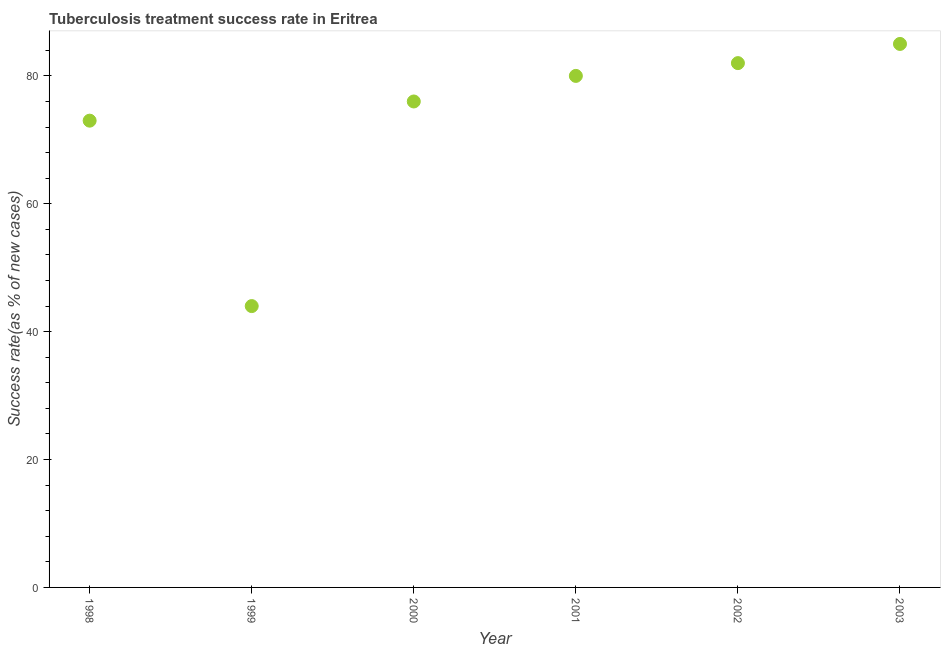What is the tuberculosis treatment success rate in 1998?
Offer a very short reply. 73. Across all years, what is the maximum tuberculosis treatment success rate?
Your answer should be compact. 85. Across all years, what is the minimum tuberculosis treatment success rate?
Your answer should be very brief. 44. In which year was the tuberculosis treatment success rate minimum?
Provide a succinct answer. 1999. What is the sum of the tuberculosis treatment success rate?
Make the answer very short. 440. What is the difference between the tuberculosis treatment success rate in 2000 and 2003?
Make the answer very short. -9. What is the average tuberculosis treatment success rate per year?
Your response must be concise. 73.33. In how many years, is the tuberculosis treatment success rate greater than 44 %?
Provide a succinct answer. 5. Do a majority of the years between 1999 and 2003 (inclusive) have tuberculosis treatment success rate greater than 36 %?
Make the answer very short. Yes. What is the ratio of the tuberculosis treatment success rate in 2000 to that in 2003?
Provide a succinct answer. 0.89. Is the tuberculosis treatment success rate in 2000 less than that in 2001?
Your answer should be compact. Yes. Is the difference between the tuberculosis treatment success rate in 1999 and 2003 greater than the difference between any two years?
Keep it short and to the point. Yes. What is the difference between the highest and the second highest tuberculosis treatment success rate?
Give a very brief answer. 3. Is the sum of the tuberculosis treatment success rate in 2002 and 2003 greater than the maximum tuberculosis treatment success rate across all years?
Your answer should be very brief. Yes. What is the difference between the highest and the lowest tuberculosis treatment success rate?
Keep it short and to the point. 41. Does the tuberculosis treatment success rate monotonically increase over the years?
Ensure brevity in your answer.  No. How many dotlines are there?
Give a very brief answer. 1. Are the values on the major ticks of Y-axis written in scientific E-notation?
Your answer should be compact. No. Does the graph contain any zero values?
Provide a short and direct response. No. What is the title of the graph?
Offer a terse response. Tuberculosis treatment success rate in Eritrea. What is the label or title of the Y-axis?
Keep it short and to the point. Success rate(as % of new cases). What is the Success rate(as % of new cases) in 1999?
Offer a very short reply. 44. What is the Success rate(as % of new cases) in 2000?
Make the answer very short. 76. What is the Success rate(as % of new cases) in 2001?
Offer a very short reply. 80. What is the difference between the Success rate(as % of new cases) in 1998 and 2000?
Your answer should be compact. -3. What is the difference between the Success rate(as % of new cases) in 1998 and 2001?
Offer a very short reply. -7. What is the difference between the Success rate(as % of new cases) in 1999 and 2000?
Give a very brief answer. -32. What is the difference between the Success rate(as % of new cases) in 1999 and 2001?
Your answer should be compact. -36. What is the difference between the Success rate(as % of new cases) in 1999 and 2002?
Offer a terse response. -38. What is the difference between the Success rate(as % of new cases) in 1999 and 2003?
Your answer should be very brief. -41. What is the difference between the Success rate(as % of new cases) in 2000 and 2002?
Provide a succinct answer. -6. What is the difference between the Success rate(as % of new cases) in 2001 and 2002?
Ensure brevity in your answer.  -2. What is the difference between the Success rate(as % of new cases) in 2001 and 2003?
Your response must be concise. -5. What is the difference between the Success rate(as % of new cases) in 2002 and 2003?
Make the answer very short. -3. What is the ratio of the Success rate(as % of new cases) in 1998 to that in 1999?
Provide a succinct answer. 1.66. What is the ratio of the Success rate(as % of new cases) in 1998 to that in 2000?
Your answer should be very brief. 0.96. What is the ratio of the Success rate(as % of new cases) in 1998 to that in 2001?
Ensure brevity in your answer.  0.91. What is the ratio of the Success rate(as % of new cases) in 1998 to that in 2002?
Provide a succinct answer. 0.89. What is the ratio of the Success rate(as % of new cases) in 1998 to that in 2003?
Your answer should be compact. 0.86. What is the ratio of the Success rate(as % of new cases) in 1999 to that in 2000?
Your answer should be very brief. 0.58. What is the ratio of the Success rate(as % of new cases) in 1999 to that in 2001?
Ensure brevity in your answer.  0.55. What is the ratio of the Success rate(as % of new cases) in 1999 to that in 2002?
Give a very brief answer. 0.54. What is the ratio of the Success rate(as % of new cases) in 1999 to that in 2003?
Offer a terse response. 0.52. What is the ratio of the Success rate(as % of new cases) in 2000 to that in 2002?
Offer a terse response. 0.93. What is the ratio of the Success rate(as % of new cases) in 2000 to that in 2003?
Offer a terse response. 0.89. What is the ratio of the Success rate(as % of new cases) in 2001 to that in 2003?
Your response must be concise. 0.94. 